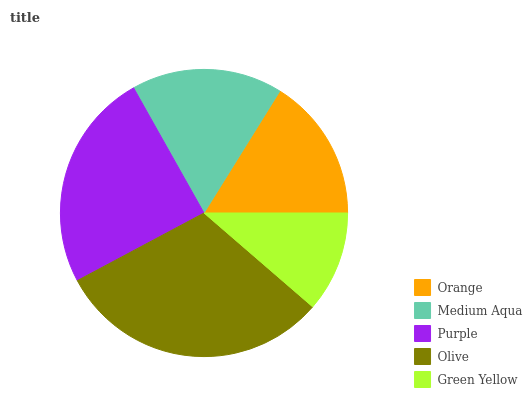Is Green Yellow the minimum?
Answer yes or no. Yes. Is Olive the maximum?
Answer yes or no. Yes. Is Medium Aqua the minimum?
Answer yes or no. No. Is Medium Aqua the maximum?
Answer yes or no. No. Is Medium Aqua greater than Orange?
Answer yes or no. Yes. Is Orange less than Medium Aqua?
Answer yes or no. Yes. Is Orange greater than Medium Aqua?
Answer yes or no. No. Is Medium Aqua less than Orange?
Answer yes or no. No. Is Medium Aqua the high median?
Answer yes or no. Yes. Is Medium Aqua the low median?
Answer yes or no. Yes. Is Olive the high median?
Answer yes or no. No. Is Olive the low median?
Answer yes or no. No. 